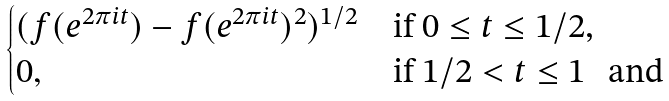<formula> <loc_0><loc_0><loc_500><loc_500>\begin{cases} ( f ( e ^ { 2 \pi i t } ) - f ( e ^ { 2 \pi i t } ) ^ { 2 } ) ^ { 1 / 2 } & \text {if $0\leq t\leq 1/2$,} \\ 0 , & \text {if $1/2<t\leq 1$ \, and} \end{cases}</formula> 